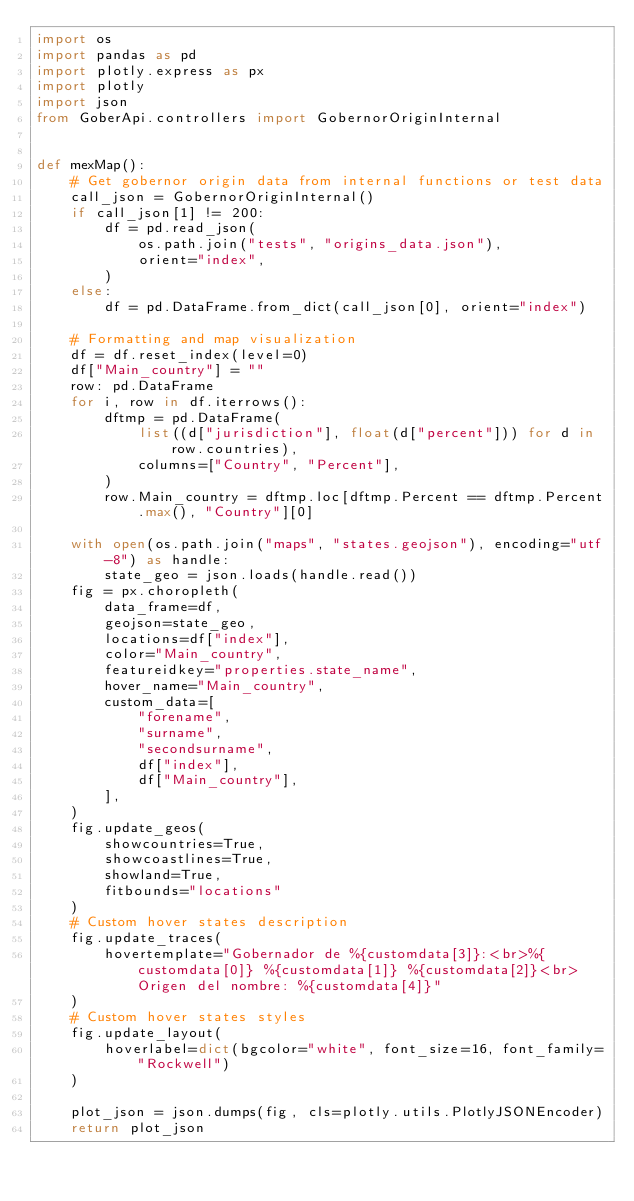<code> <loc_0><loc_0><loc_500><loc_500><_Python_>import os
import pandas as pd
import plotly.express as px
import plotly
import json
from GoberApi.controllers import GobernorOriginInternal


def mexMap():
    # Get gobernor origin data from internal functions or test data
    call_json = GobernorOriginInternal()
    if call_json[1] != 200:
        df = pd.read_json(
            os.path.join("tests", "origins_data.json"),
            orient="index",
        )
    else:
        df = pd.DataFrame.from_dict(call_json[0], orient="index")

    # Formatting and map visualization
    df = df.reset_index(level=0)
    df["Main_country"] = ""
    row: pd.DataFrame
    for i, row in df.iterrows():
        dftmp = pd.DataFrame(
            list((d["jurisdiction"], float(d["percent"])) for d in row.countries),
            columns=["Country", "Percent"],
        )
        row.Main_country = dftmp.loc[dftmp.Percent == dftmp.Percent.max(), "Country"][0]

    with open(os.path.join("maps", "states.geojson"), encoding="utf-8") as handle:
        state_geo = json.loads(handle.read())
    fig = px.choropleth(
        data_frame=df,
        geojson=state_geo,
        locations=df["index"],
        color="Main_country",
        featureidkey="properties.state_name",
        hover_name="Main_country",
        custom_data=[
            "forename",
            "surname",
            "secondsurname",
            df["index"],
            df["Main_country"],
        ],
    )
    fig.update_geos(
        showcountries=True,
        showcoastlines=True,
        showland=True,
        fitbounds="locations"
    )
    # Custom hover states description
    fig.update_traces(
        hovertemplate="Gobernador de %{customdata[3]}:<br>%{customdata[0]} %{customdata[1]} %{customdata[2]}<br>Origen del nombre: %{customdata[4]}"
    )
    # Custom hover states styles
    fig.update_layout(
        hoverlabel=dict(bgcolor="white", font_size=16, font_family="Rockwell")
    )

    plot_json = json.dumps(fig, cls=plotly.utils.PlotlyJSONEncoder)
    return plot_json
</code> 